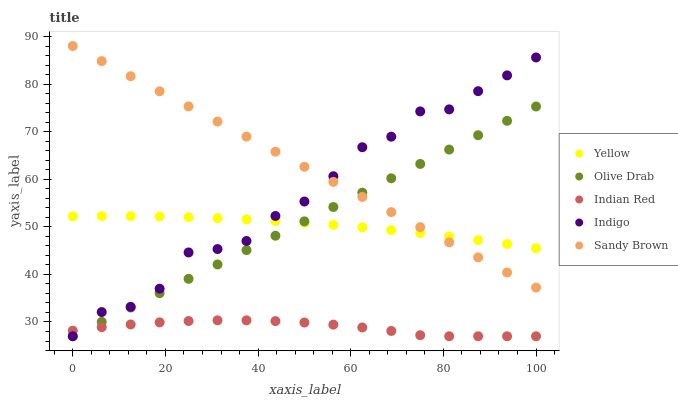Does Indian Red have the minimum area under the curve?
Answer yes or no. Yes. Does Sandy Brown have the maximum area under the curve?
Answer yes or no. Yes. Does Indigo have the minimum area under the curve?
Answer yes or no. No. Does Indigo have the maximum area under the curve?
Answer yes or no. No. Is Sandy Brown the smoothest?
Answer yes or no. Yes. Is Indigo the roughest?
Answer yes or no. Yes. Is Indigo the smoothest?
Answer yes or no. No. Is Sandy Brown the roughest?
Answer yes or no. No. Does Indian Red have the lowest value?
Answer yes or no. Yes. Does Sandy Brown have the lowest value?
Answer yes or no. No. Does Sandy Brown have the highest value?
Answer yes or no. Yes. Does Indigo have the highest value?
Answer yes or no. No. Is Indian Red less than Yellow?
Answer yes or no. Yes. Is Yellow greater than Indian Red?
Answer yes or no. Yes. Does Olive Drab intersect Sandy Brown?
Answer yes or no. Yes. Is Olive Drab less than Sandy Brown?
Answer yes or no. No. Is Olive Drab greater than Sandy Brown?
Answer yes or no. No. Does Indian Red intersect Yellow?
Answer yes or no. No. 